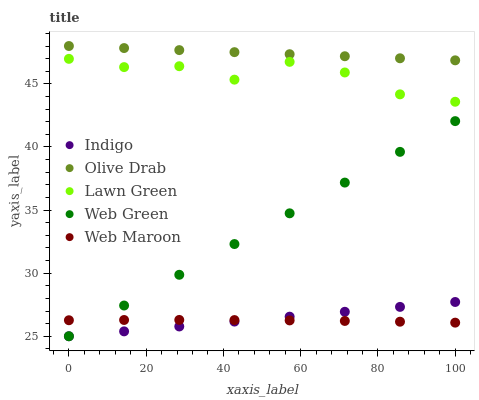Does Web Maroon have the minimum area under the curve?
Answer yes or no. Yes. Does Olive Drab have the maximum area under the curve?
Answer yes or no. Yes. Does Lawn Green have the minimum area under the curve?
Answer yes or no. No. Does Lawn Green have the maximum area under the curve?
Answer yes or no. No. Is Indigo the smoothest?
Answer yes or no. Yes. Is Lawn Green the roughest?
Answer yes or no. Yes. Is Lawn Green the smoothest?
Answer yes or no. No. Is Indigo the roughest?
Answer yes or no. No. Does Indigo have the lowest value?
Answer yes or no. Yes. Does Lawn Green have the lowest value?
Answer yes or no. No. Does Olive Drab have the highest value?
Answer yes or no. Yes. Does Lawn Green have the highest value?
Answer yes or no. No. Is Web Green less than Olive Drab?
Answer yes or no. Yes. Is Olive Drab greater than Web Maroon?
Answer yes or no. Yes. Does Web Green intersect Web Maroon?
Answer yes or no. Yes. Is Web Green less than Web Maroon?
Answer yes or no. No. Is Web Green greater than Web Maroon?
Answer yes or no. No. Does Web Green intersect Olive Drab?
Answer yes or no. No. 